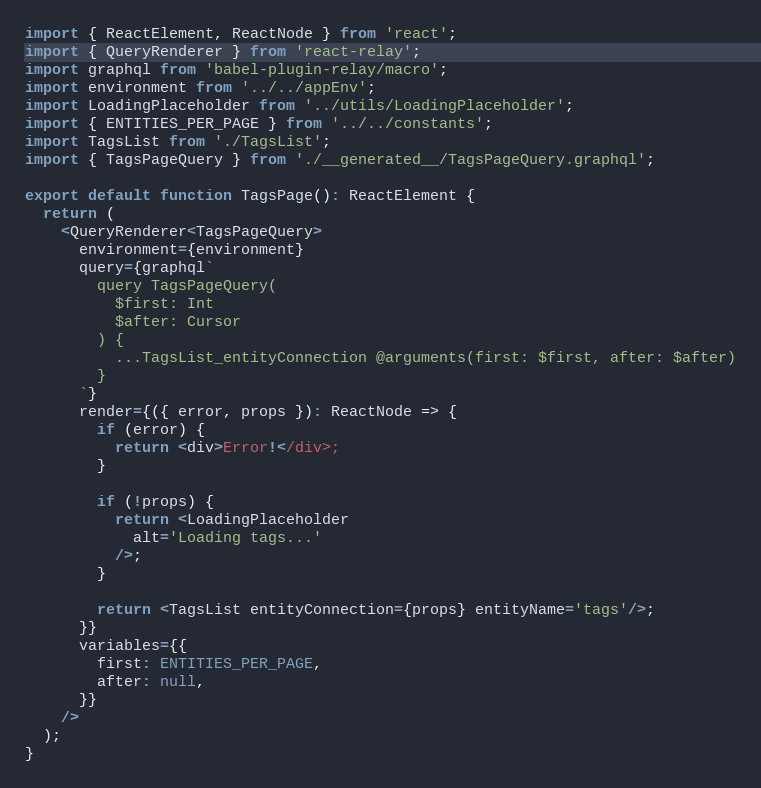Convert code to text. <code><loc_0><loc_0><loc_500><loc_500><_TypeScript_>import { ReactElement, ReactNode } from 'react';
import { QueryRenderer } from 'react-relay';
import graphql from 'babel-plugin-relay/macro';
import environment from '../../appEnv';
import LoadingPlaceholder from '../utils/LoadingPlaceholder';
import { ENTITIES_PER_PAGE } from '../../constants';
import TagsList from './TagsList';
import { TagsPageQuery } from './__generated__/TagsPageQuery.graphql';

export default function TagsPage(): ReactElement {
  return (
    <QueryRenderer<TagsPageQuery>
      environment={environment}
      query={graphql`
        query TagsPageQuery(
          $first: Int
          $after: Cursor
        ) {
          ...TagsList_entityConnection @arguments(first: $first, after: $after)
        }
      `}
      render={({ error, props }): ReactNode => {
        if (error) {
          return <div>Error!</div>;
        }

        if (!props) {
          return <LoadingPlaceholder
            alt='Loading tags...'
          />;
        }

        return <TagsList entityConnection={props} entityName='tags'/>;
      }}
      variables={{
        first: ENTITIES_PER_PAGE,
        after: null,
      }}
    />
  );
}
</code> 